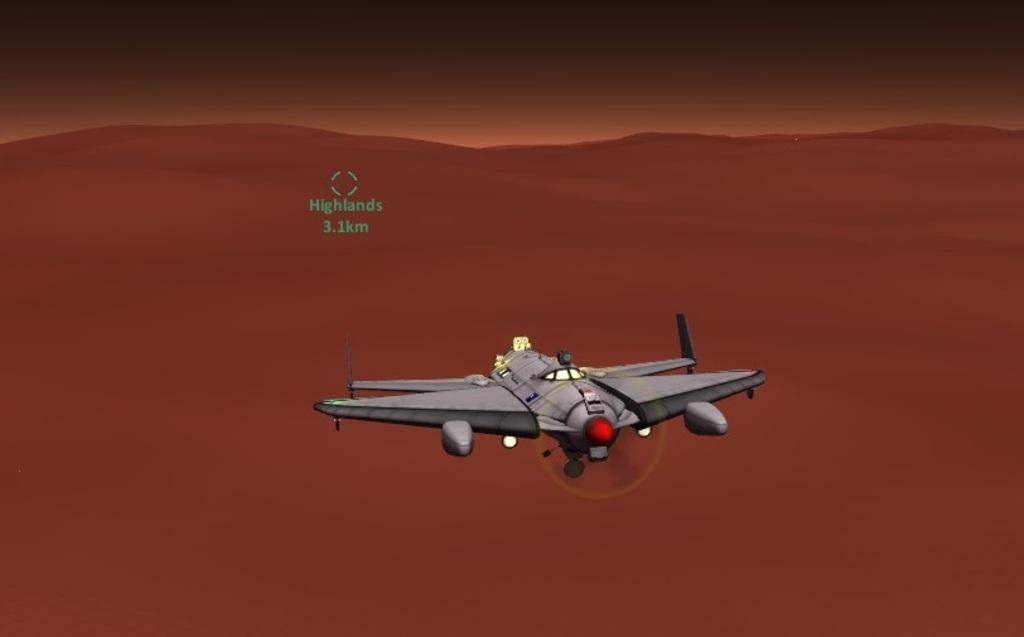What is the dominant color of the image? The image is in brown color. What type of image is it? The image is graphical. What can be seen in the image? There is an airplane flying in the image. Where is the chicken located in the image? There is no chicken present in the image. What type of screw is used to hold the wheel of the airplane in the image? There is no wheel or screw mentioned in the image, as it only features an airplane flying. 